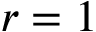Convert formula to latex. <formula><loc_0><loc_0><loc_500><loc_500>r = 1</formula> 